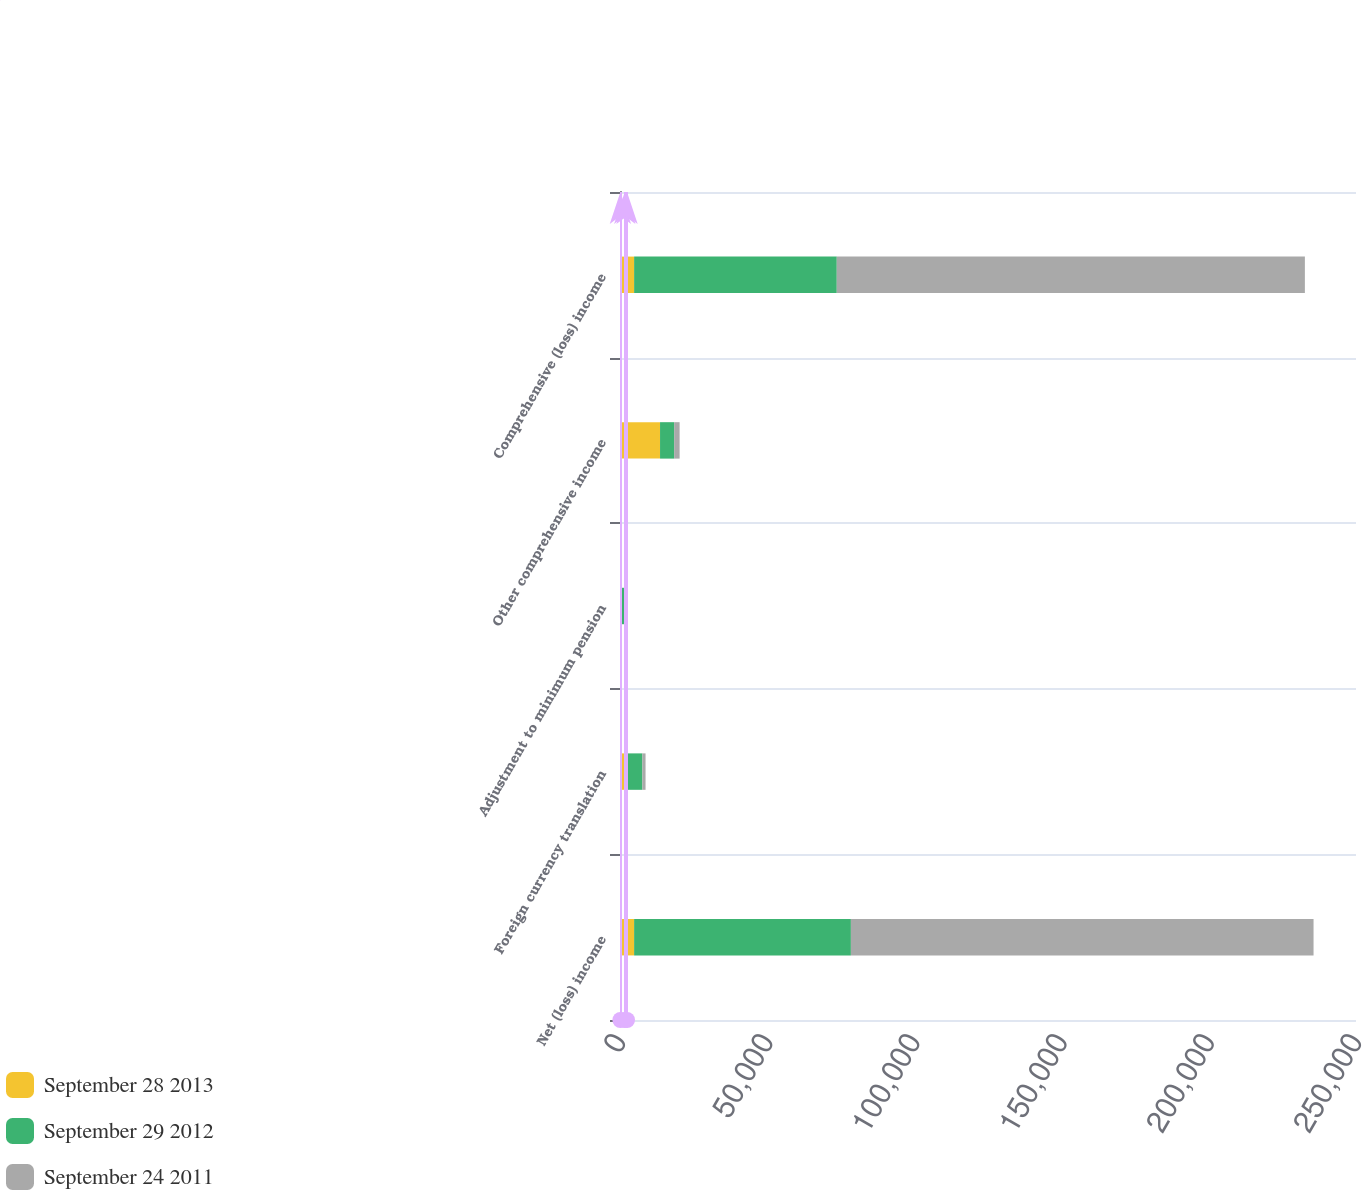<chart> <loc_0><loc_0><loc_500><loc_500><stacked_bar_chart><ecel><fcel>Net (loss) income<fcel>Foreign currency translation<fcel>Adjustment to minimum pension<fcel>Other comprehensive income<fcel>Comprehensive (loss) income<nl><fcel>September 28 2013<fcel>4795<fcel>1373<fcel>134<fcel>13601<fcel>4795<nl><fcel>September 29 2012<fcel>73634<fcel>6217<fcel>1484<fcel>4795<fcel>68839<nl><fcel>September 24 2011<fcel>157150<fcel>1088<fcel>764<fcel>1852<fcel>159002<nl></chart> 